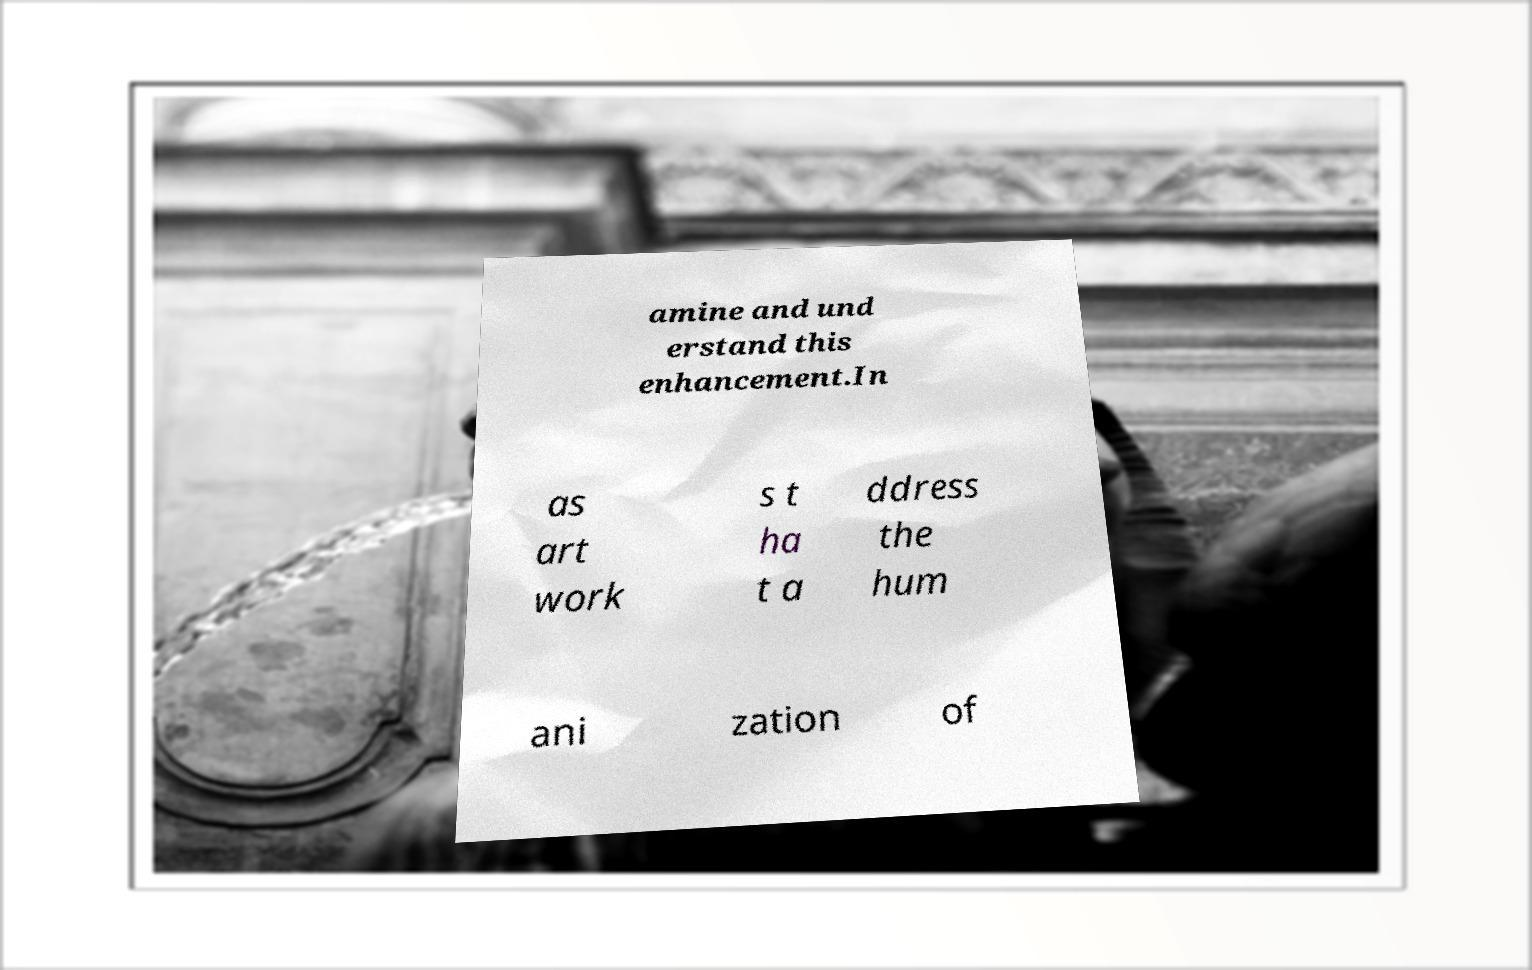Please identify and transcribe the text found in this image. amine and und erstand this enhancement.In as art work s t ha t a ddress the hum ani zation of 